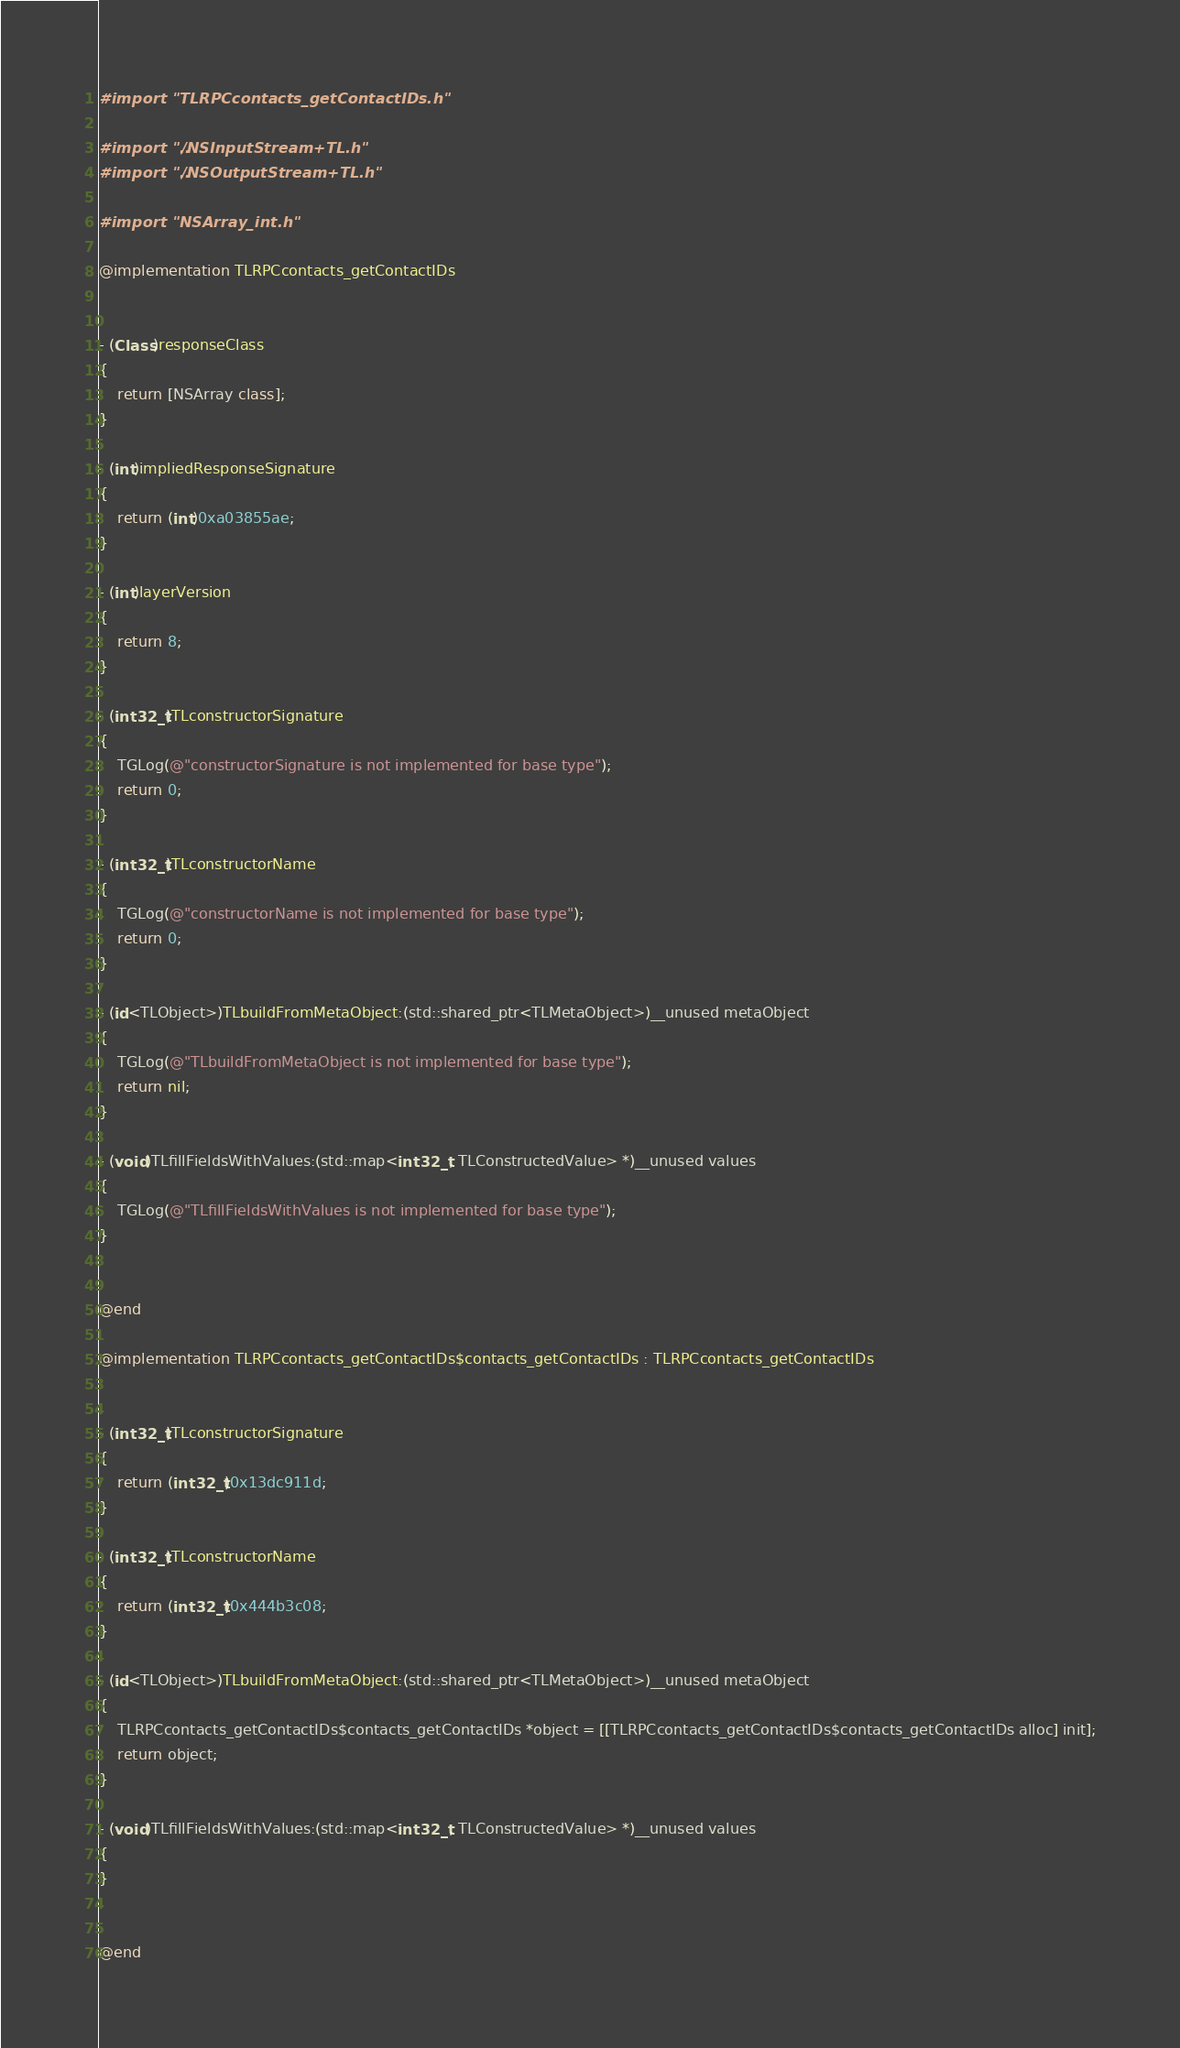<code> <loc_0><loc_0><loc_500><loc_500><_ObjectiveC_>#import "TLRPCcontacts_getContactIDs.h"

#import "../NSInputStream+TL.h"
#import "../NSOutputStream+TL.h"

#import "NSArray_int.h"

@implementation TLRPCcontacts_getContactIDs


- (Class)responseClass
{
    return [NSArray class];
}

- (int)impliedResponseSignature
{
    return (int)0xa03855ae;
}

- (int)layerVersion
{
    return 8;
}

- (int32_t)TLconstructorSignature
{
    TGLog(@"constructorSignature is not implemented for base type");
    return 0;
}

- (int32_t)TLconstructorName
{
    TGLog(@"constructorName is not implemented for base type");
    return 0;
}

- (id<TLObject>)TLbuildFromMetaObject:(std::shared_ptr<TLMetaObject>)__unused metaObject
{
    TGLog(@"TLbuildFromMetaObject is not implemented for base type");
    return nil;
}

- (void)TLfillFieldsWithValues:(std::map<int32_t, TLConstructedValue> *)__unused values
{
    TGLog(@"TLfillFieldsWithValues is not implemented for base type");
}


@end

@implementation TLRPCcontacts_getContactIDs$contacts_getContactIDs : TLRPCcontacts_getContactIDs


- (int32_t)TLconstructorSignature
{
    return (int32_t)0x13dc911d;
}

- (int32_t)TLconstructorName
{
    return (int32_t)0x444b3c08;
}

- (id<TLObject>)TLbuildFromMetaObject:(std::shared_ptr<TLMetaObject>)__unused metaObject
{
    TLRPCcontacts_getContactIDs$contacts_getContactIDs *object = [[TLRPCcontacts_getContactIDs$contacts_getContactIDs alloc] init];
    return object;
}

- (void)TLfillFieldsWithValues:(std::map<int32_t, TLConstructedValue> *)__unused values
{
}


@end

</code> 